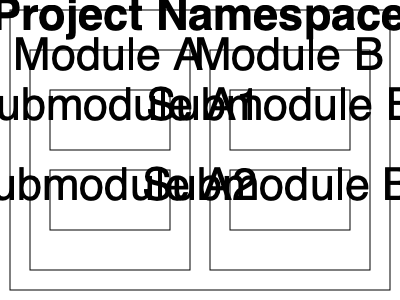In the given namespace hierarchy diagram for a large-scale software project, what is the most efficient way to reference a class or function in Submodule B2 from code within Submodule A1? To efficiently reference a class or function in Submodule B2 from Submodule A1, we need to consider the namespace structure and follow these steps:

1. Analyze the hierarchy:
   - Both submodules are within the main Project Namespace
   - Submodule A1 is inside Module A
   - Submodule B2 is inside Module B

2. Determine the relative path:
   - We need to go up two levels from Submodule A1 to reach the Project Namespace
   - Then we need to go down two levels to reach Submodule B2

3. Use the appropriate namespace referencing syntax:
   - In most programming languages, we use double colons (::) to separate namespace levels
   - We start with the top-level namespace and work our way down

4. Construct the reference:
   - Start with the Project Namespace (assumed to be the global namespace)
   - Add Module B
   - Add Submodule B2
   - Add the specific class or function name

5. Optimize the reference:
   - To make the code more maintainable and reduce typing, we can use a "using" statement or import at the beginning of the file in Submodule A1
   - This allows us to reference the Submodule B2 namespace directly

The most efficient way to reference a class or function in Submodule B2 from Submodule A1 would be to use a "using" statement or import for the Submodule B2 namespace at the beginning of the file, and then directly use the class or function name within the code.
Answer: Use a "using" statement for Submodule B2's namespace, then directly reference the class or function. 